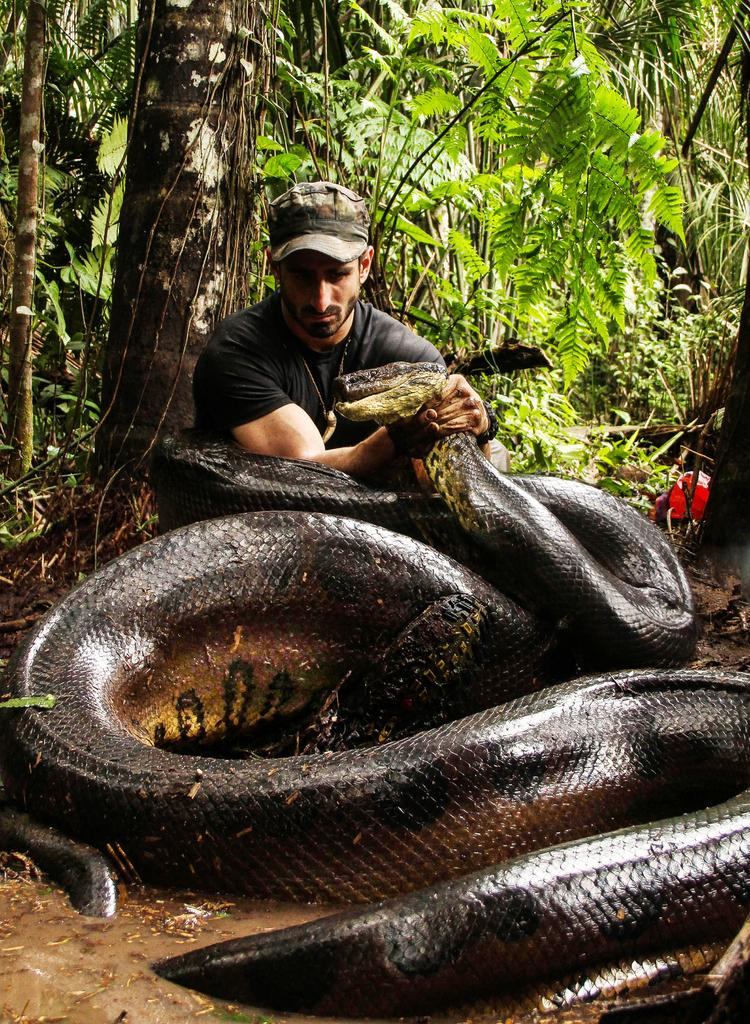What is the person holding in the image? The person is holding a snake. What can be seen in the background of the image? There are branches and green leaves visible in the background of the image. What type of steel is used to make the whistle in the image? There is no whistle present in the image, so it is not possible to determine what type of steel might be used. 